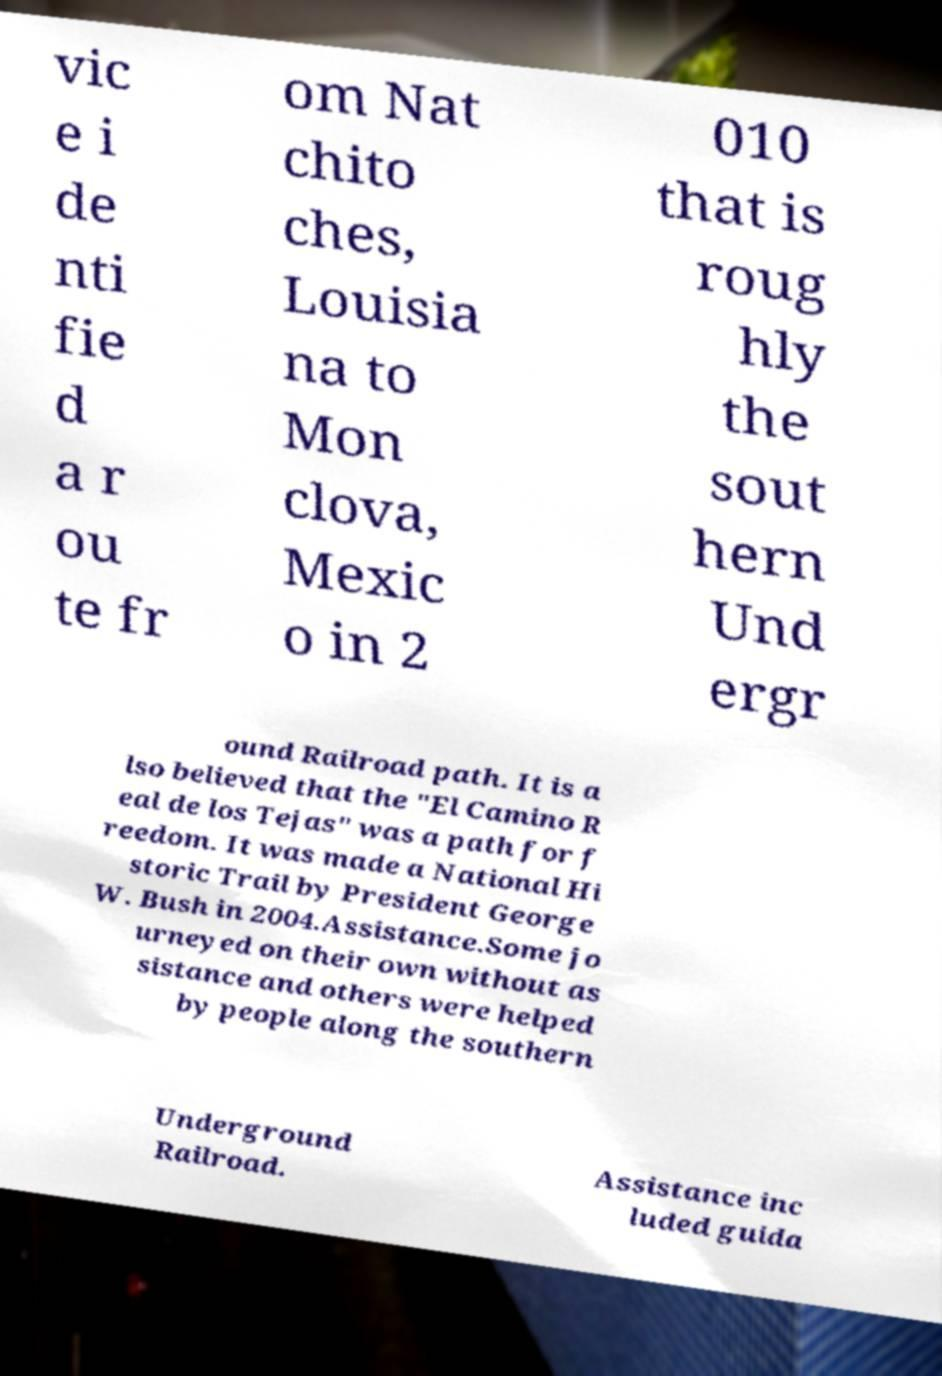I need the written content from this picture converted into text. Can you do that? vic e i de nti fie d a r ou te fr om Nat chito ches, Louisia na to Mon clova, Mexic o in 2 010 that is roug hly the sout hern Und ergr ound Railroad path. It is a lso believed that the "El Camino R eal de los Tejas" was a path for f reedom. It was made a National Hi storic Trail by President George W. Bush in 2004.Assistance.Some jo urneyed on their own without as sistance and others were helped by people along the southern Underground Railroad. Assistance inc luded guida 